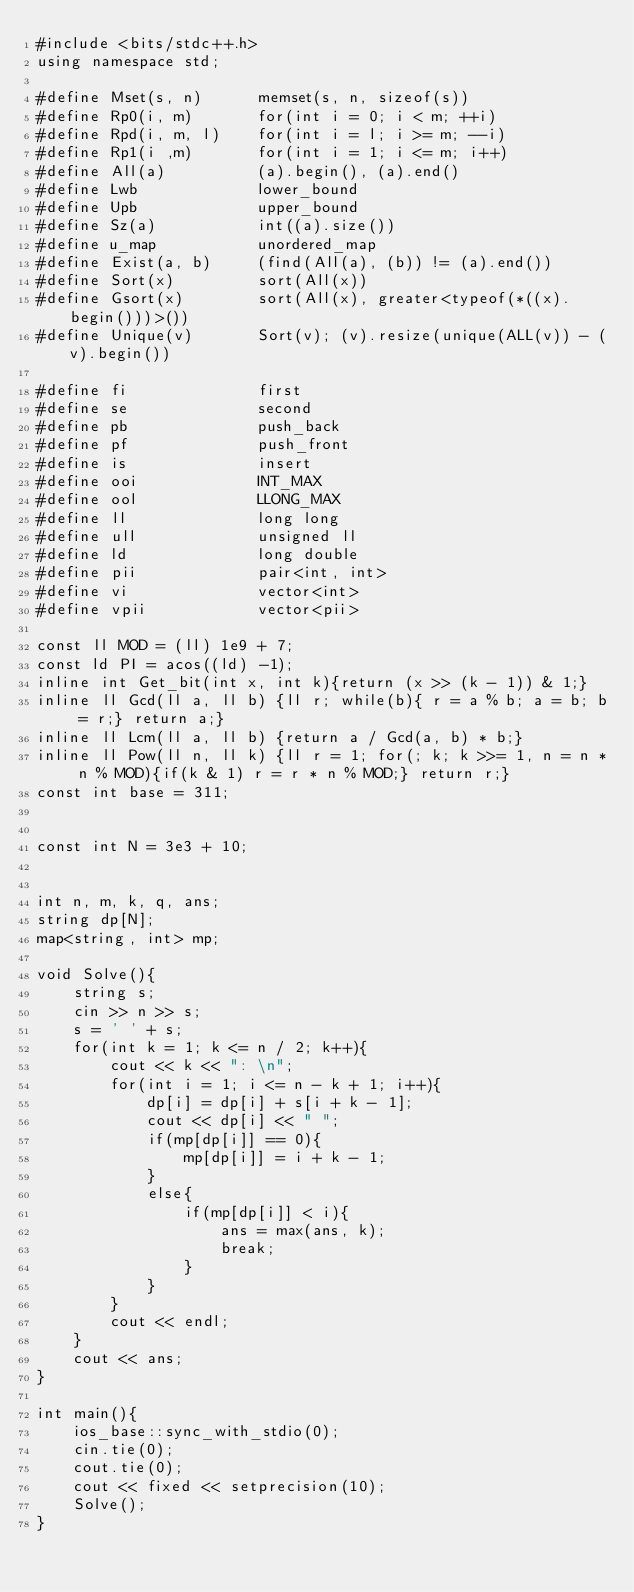<code> <loc_0><loc_0><loc_500><loc_500><_C++_>#include <bits/stdc++.h>
using namespace std;

#define Mset(s, n)      memset(s, n, sizeof(s))
#define Rp0(i, m)       for(int i = 0; i < m; ++i)
#define Rpd(i, m, l)    for(int i = l; i >= m; --i)
#define Rp1(i ,m)       for(int i = 1; i <= m; i++)
#define All(a)          (a).begin(), (a).end()
#define Lwb             lower_bound
#define Upb             upper_bound
#define Sz(a)           int((a).size())
#define u_map           unordered_map
#define Exist(a, b)     (find(All(a), (b)) != (a).end())
#define Sort(x)         sort(All(x))
#define Gsort(x)        sort(All(x), greater<typeof(*((x).begin()))>())
#define Unique(v)       Sort(v); (v).resize(unique(ALL(v)) - (v).begin())

#define fi              first
#define se              second
#define pb              push_back
#define pf              push_front
#define is              insert
#define ooi             INT_MAX
#define ool             LLONG_MAX
#define ll              long long
#define ull             unsigned ll
#define ld              long double
#define pii             pair<int, int>
#define vi              vector<int>
#define vpii            vector<pii>

const ll MOD = (ll) 1e9 + 7;
const ld PI = acos((ld) -1);
inline int Get_bit(int x, int k){return (x >> (k - 1)) & 1;}
inline ll Gcd(ll a, ll b) {ll r; while(b){ r = a % b; a = b; b = r;} return a;}
inline ll Lcm(ll a, ll b) {return a / Gcd(a, b) * b;}
inline ll Pow(ll n, ll k) {ll r = 1; for(; k; k >>= 1, n = n * n % MOD){if(k & 1) r = r * n % MOD;} return r;}
const int base = 311;


const int N = 3e3 + 10;


int n, m, k, q, ans;
string dp[N];
map<string, int> mp;

void Solve(){
    string s;
    cin >> n >> s;
    s = ' ' + s;
    for(int k = 1; k <= n / 2; k++){
        cout << k << ": \n";
        for(int i = 1; i <= n - k + 1; i++){
            dp[i] = dp[i] + s[i + k - 1];
            cout << dp[i] << " ";
            if(mp[dp[i]] == 0){
                mp[dp[i]] = i + k - 1;
            }
            else{
                if(mp[dp[i]] < i){
                    ans = max(ans, k);
                    break;
                }
            }
        }
        cout << endl;
    }
    cout << ans;
}

int main(){
    ios_base::sync_with_stdio(0);
    cin.tie(0);
    cout.tie(0);
    cout << fixed << setprecision(10);
    Solve();
}








</code> 